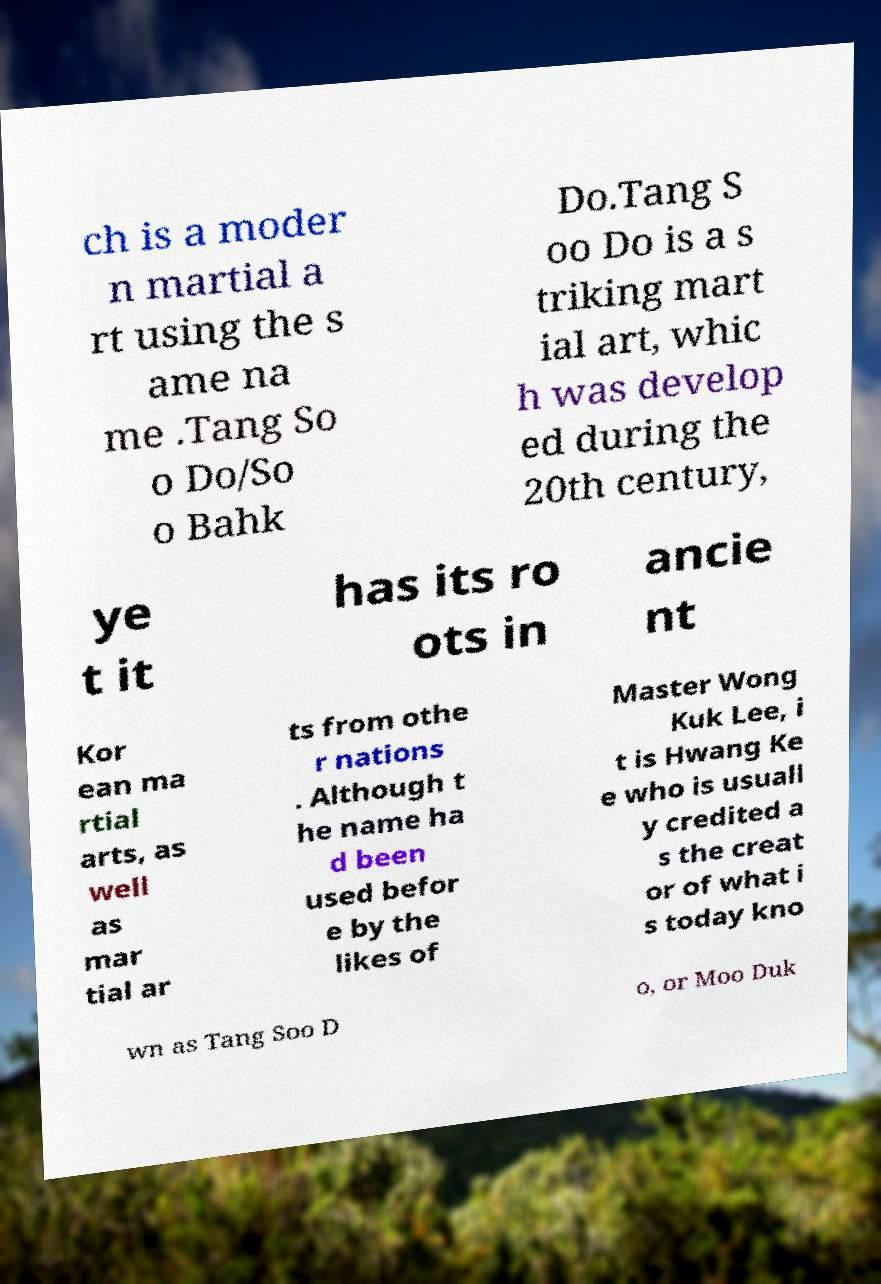Could you assist in decoding the text presented in this image and type it out clearly? ch is a moder n martial a rt using the s ame na me .Tang So o Do/So o Bahk Do.Tang S oo Do is a s triking mart ial art, whic h was develop ed during the 20th century, ye t it has its ro ots in ancie nt Kor ean ma rtial arts, as well as mar tial ar ts from othe r nations . Although t he name ha d been used befor e by the likes of Master Wong Kuk Lee, i t is Hwang Ke e who is usuall y credited a s the creat or of what i s today kno wn as Tang Soo D o, or Moo Duk 